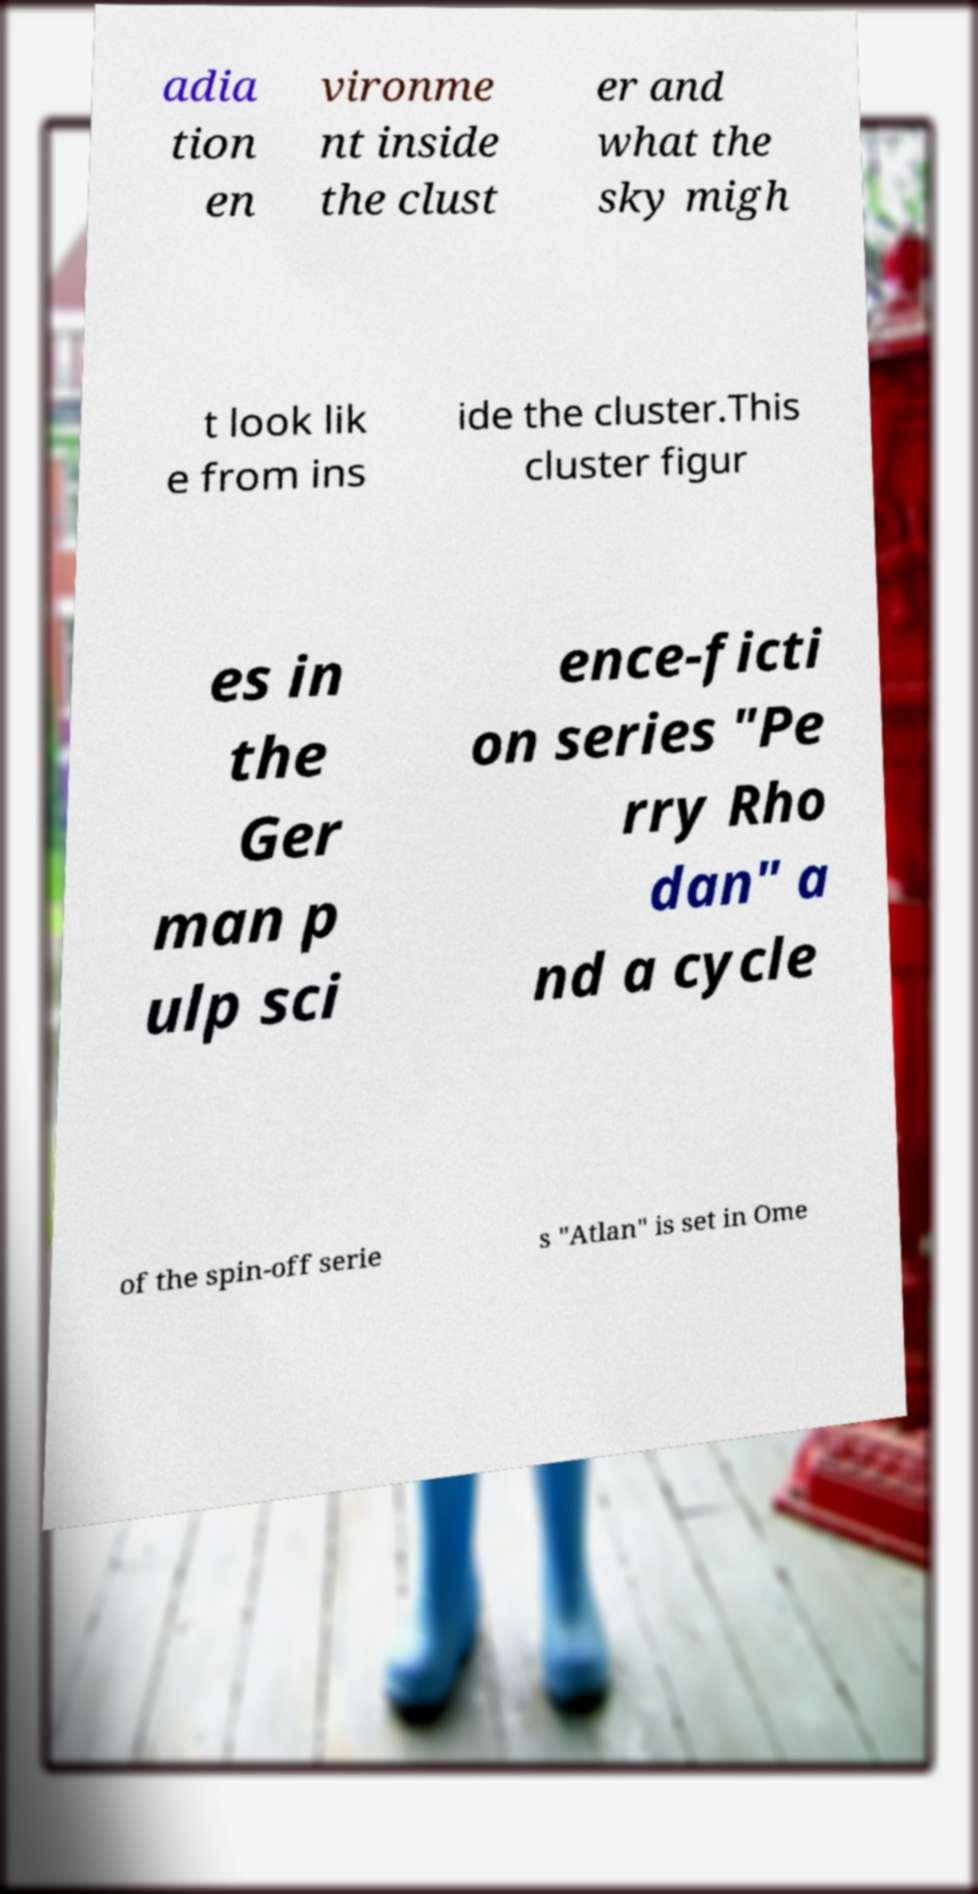There's text embedded in this image that I need extracted. Can you transcribe it verbatim? adia tion en vironme nt inside the clust er and what the sky migh t look lik e from ins ide the cluster.This cluster figur es in the Ger man p ulp sci ence-ficti on series "Pe rry Rho dan" a nd a cycle of the spin-off serie s "Atlan" is set in Ome 